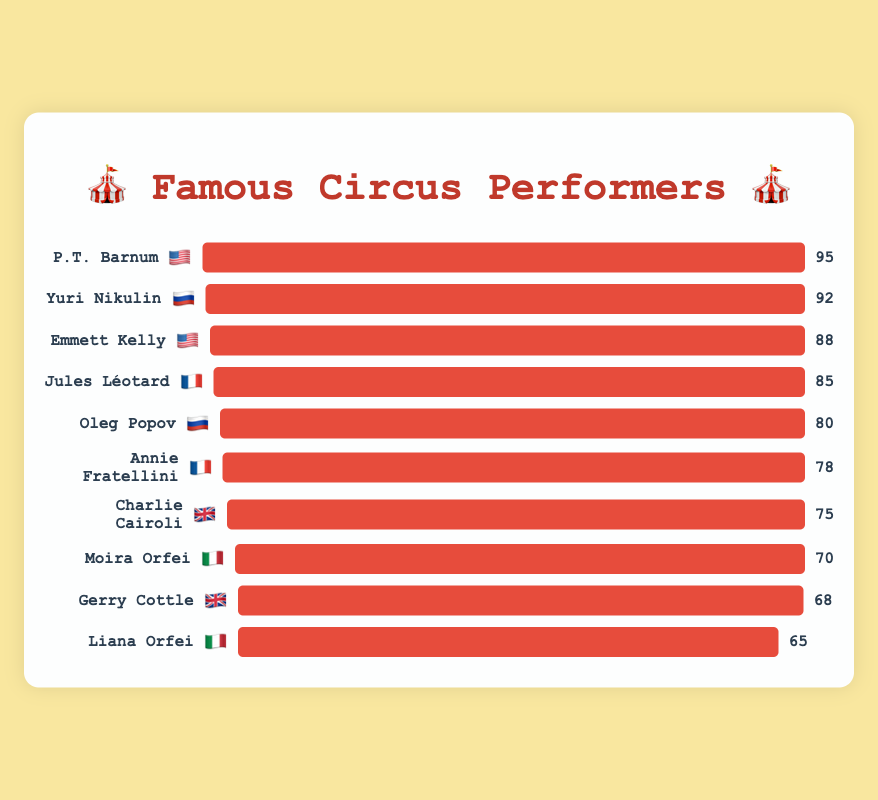What is the highest fame score in the chart? The highest fame score is visibly the longest bar in the chart. By looking at the figure, P.T. Barnum has the longest bar with 95 fame points.
Answer: 95 How many performers in the chart are from 🇮🇹 (Italy)? By counting the number of bars with the 🇮🇹 flag, there are two performers: Moira Orfei and Liana Orfei.
Answer: 2 Who has a higher fame score, Oleg Popov or Charlie Cairoli? By comparing the lengths of the bars next to the names Oleg Popov and Charlie Cairoli, Oleg Popov has a fame score of 80, whereas Charlie Cairoli has a fame score of 75.
Answer: Oleg Popov What is the sum of the fame scores for all 🇫🇷 (France) performers? Adding up the fame scores of Jules Léotard (85) and Annie Fratellini (78) gives: 85 + 78 = 163.
Answer: 163 Which nationality has the most performers on the chart? By counting the occurrences of each flag emoji next to the names, 🇺🇸 (USA) appears twice, 🇫🇷 (France) twice, 🇷🇺 (Russia) twice, 🇬🇧 (UK) twice, and 🇮🇹 (Italy) twice. There is no nationality with more performers than another.
Answer: There is no single nationality with more performers Who has the second-highest fame score, and what is their nationality? The second-longest bar after P.T. Barnum belongs to Yuri Nikulin, with a fame score of 92. His flag indicates he is from 🇷🇺 (Russia).
Answer: Yuri Nikulin, 🇷🇺 What is the average fame score of all the performers? To find the average, sum up the fame scores and divide by the number of performers. Sum = 95 + 85 + 80 + 75 + 70 + 88 + 78 + 92 + 68 + 65 = 796. Number of performers = 10. Average = 796 / 10 = 79.6
Answer: 79.6 Is there a performer with a fame score equal to 70, and who are they? By observing the chart, the fame score of 70 matches with the bar for Moira Orfei.
Answer: Moira Orfei 